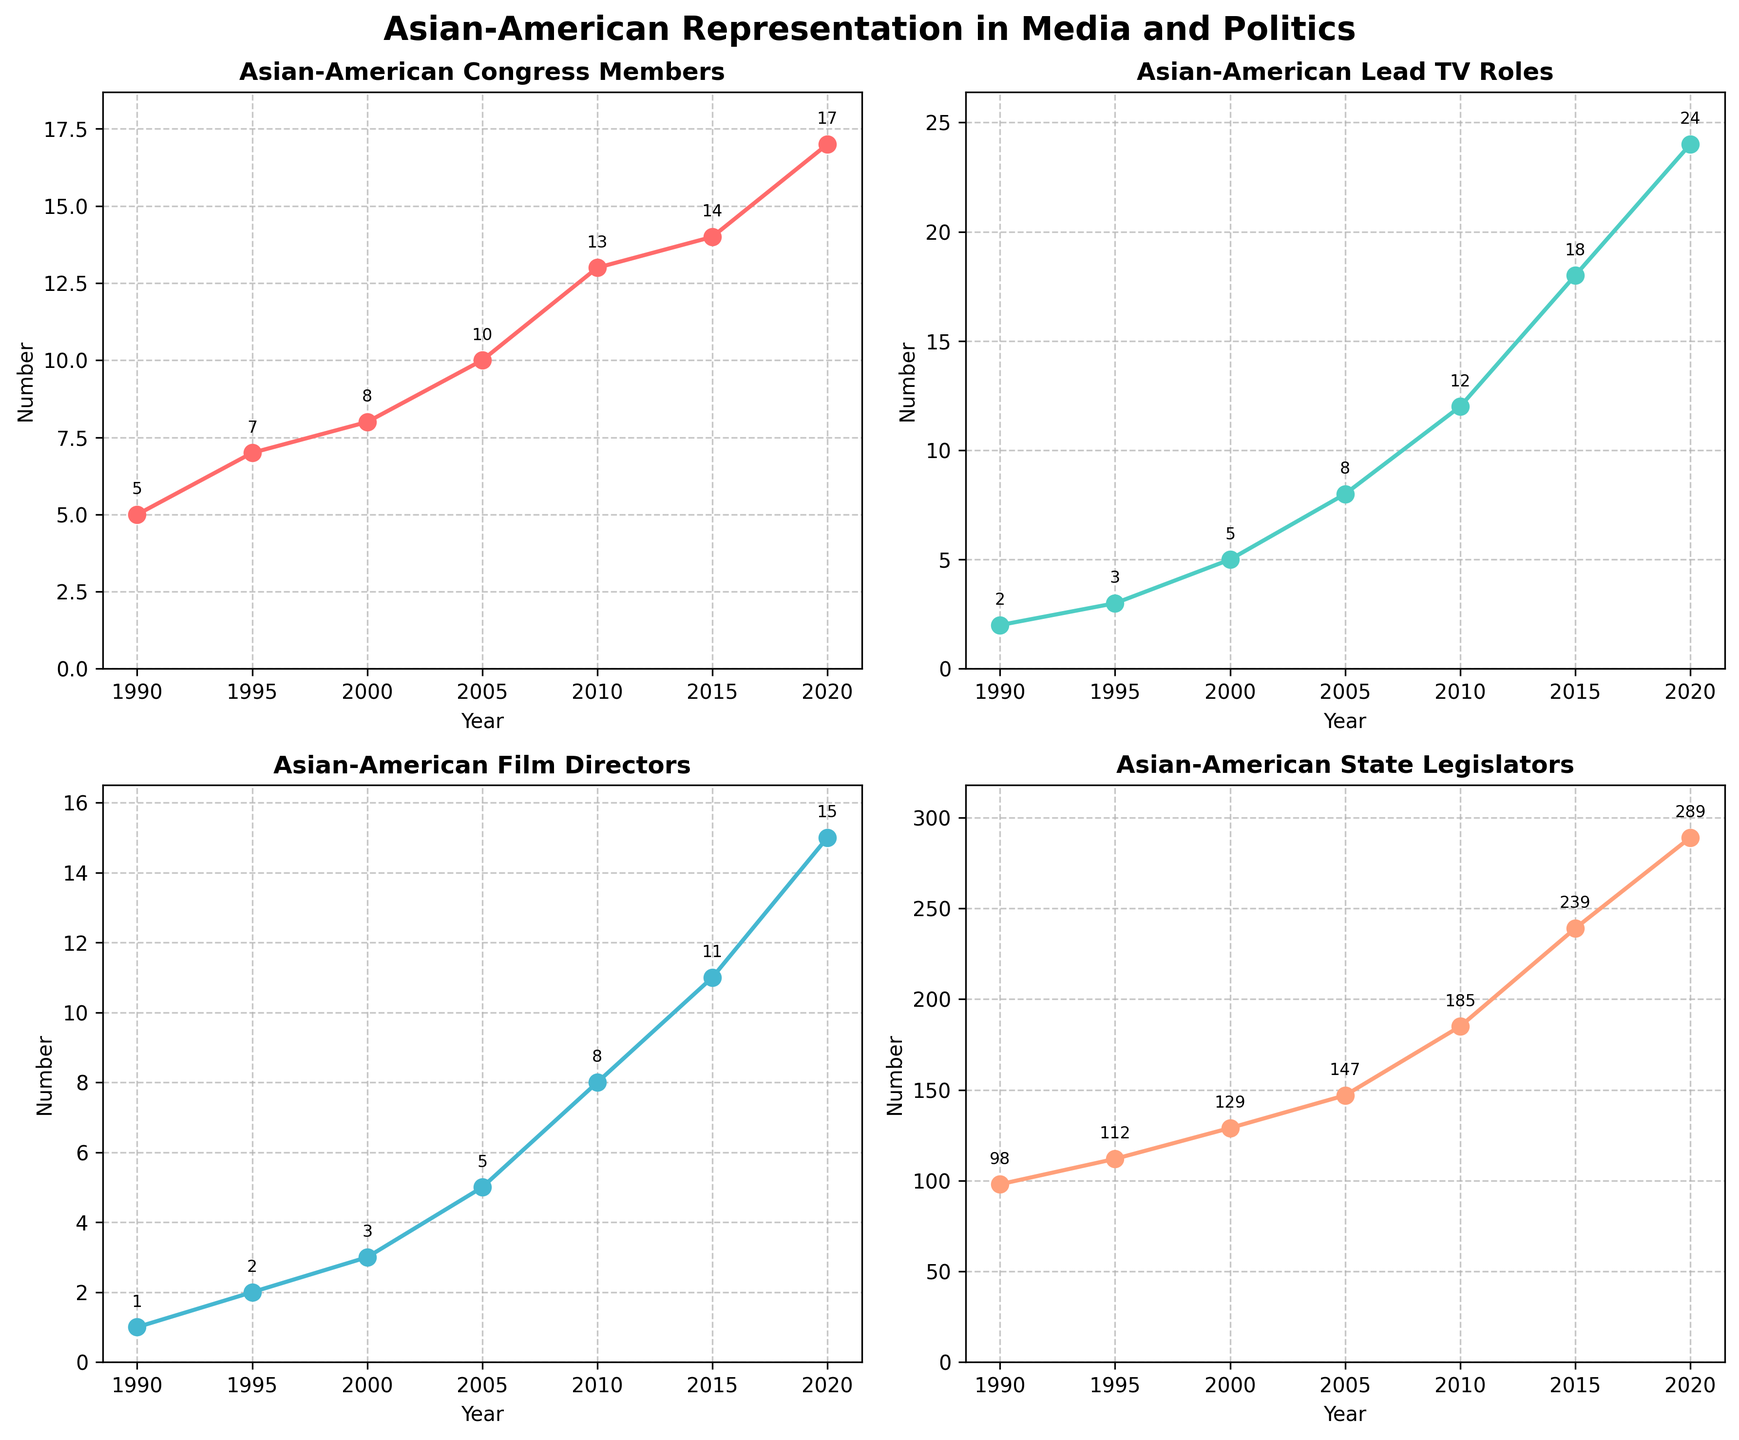What is the title of the figure? The title of the figure is at the top and provides a summary of what the visual data represents.
Answer: Asian-American Representation in Media and Politics How many subplots are in the figure? The figure grid is divided into smaller sections, with four separate plots each representing a different metric.
Answer: 4 What trend do we see in the number of Asian-American Congress Members over the years? Observing the respective subplot for Asian-American Congress Members, the plotted line shows an increasing trend from the start year to the end year.
Answer: Increasing What is the maximum number of Asian-American Lead TV Roles observed in the given period? Look at the subplot for Asian-American Lead TV Roles and find the highest data point along the y-axis.
Answer: 24 How many Asian-American Film Directors were there in 2020? The corresponding subplot for Asian-American Film Directors shows values plotted by year. Look for the data point at the year 2020.
Answer: 15 Which metric shows the most significant increase from 1990 to 2020? Compare the differences for each metric: subtract the 1990 value from 2020 value and find the greatest difference.
Answer: Asian-American State Legislators (289 - 98 = 191) Between 2005 and 2010, which metric had the highest absolute increase? Calculate the difference for each metric between 2005 and 2010, and compare them.
Answer: Asian-American State Legislators (185 - 147 = 38) What was the number of Asian-American Lead TV Roles in 2015, and how did it compare to 2020? Look at the plot for Asian-American Lead TV Roles to find values for 2015 and 2020. Lastly, compare the two values.
Answer: 18 in 2015 and 24 in 2020; increase by 6 Have any of the metrics shown a decrease at any point on the plots? Examine each subplot to see if any line trends downwards at any point from start to end year.
Answer: No 